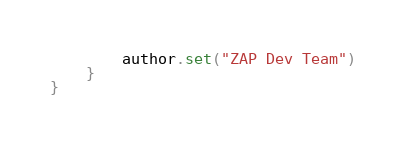<code> <loc_0><loc_0><loc_500><loc_500><_Kotlin_>        author.set("ZAP Dev Team")
    }
}
</code> 